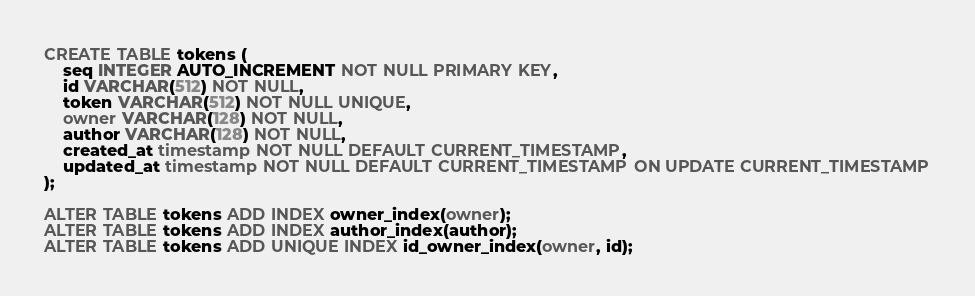Convert code to text. <code><loc_0><loc_0><loc_500><loc_500><_SQL_>CREATE TABLE tokens (
    seq INTEGER AUTO_INCREMENT NOT NULL PRIMARY KEY,
    id VARCHAR(512) NOT NULL, 
    token VARCHAR(512) NOT NULL UNIQUE,
    owner VARCHAR(128) NOT NULL,
    author VARCHAR(128) NOT NULL,
    created_at timestamp NOT NULL DEFAULT CURRENT_TIMESTAMP,
    updated_at timestamp NOT NULL DEFAULT CURRENT_TIMESTAMP ON UPDATE CURRENT_TIMESTAMP
);

ALTER TABLE tokens ADD INDEX owner_index(owner);
ALTER TABLE tokens ADD INDEX author_index(author);
ALTER TABLE tokens ADD UNIQUE INDEX id_owner_index(owner, id);</code> 